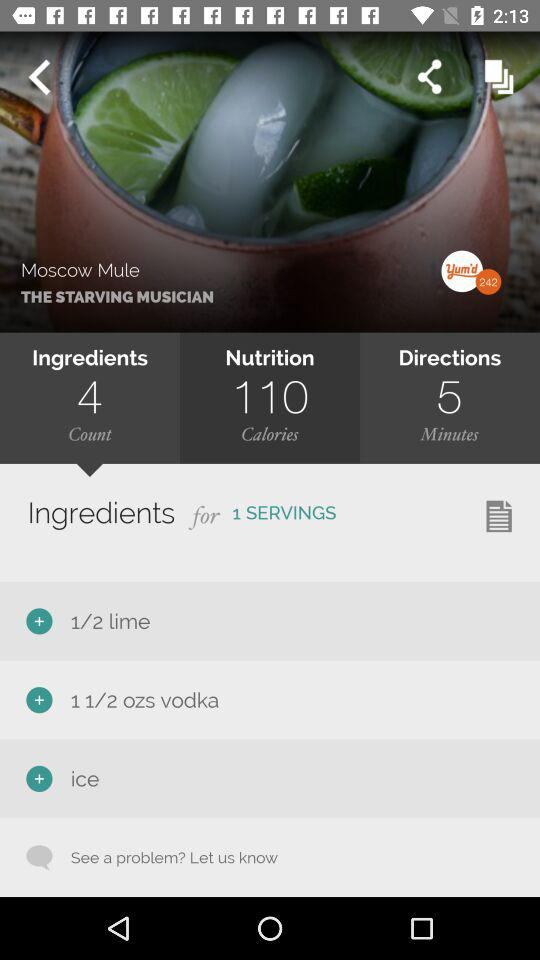What is the name of the dish? The name of the dish is "Moscow Mule". 